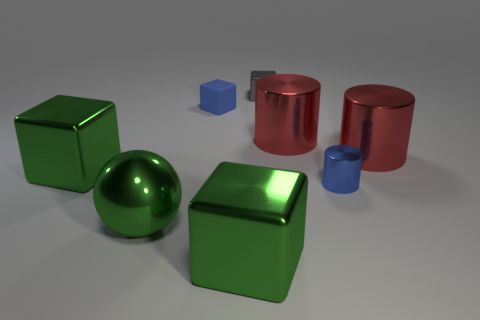There is a small thing that is in front of the large green object behind the blue shiny thing right of the tiny gray cube; what is its material?
Keep it short and to the point. Metal. There is a blue metallic thing; is it the same shape as the tiny object to the left of the tiny shiny block?
Give a very brief answer. No. What number of large red things have the same shape as the small gray metallic object?
Your answer should be very brief. 0. What is the shape of the tiny blue rubber thing?
Provide a succinct answer. Cube. There is a metal cylinder in front of the large green thing that is on the left side of the green sphere; how big is it?
Offer a terse response. Small. What number of things are either large cylinders or tiny blue metallic things?
Your answer should be compact. 3. Is the small blue metal object the same shape as the rubber thing?
Your answer should be very brief. No. Are there any small blue things that have the same material as the tiny blue cylinder?
Your answer should be compact. No. Are there any blue metal cylinders left of the metal block behind the rubber object?
Ensure brevity in your answer.  No. Do the cylinder left of the blue cylinder and the gray block have the same size?
Your answer should be compact. No. 